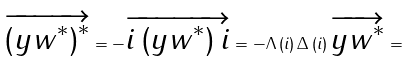Convert formula to latex. <formula><loc_0><loc_0><loc_500><loc_500>\overrightarrow { \left ( y w ^ { \ast } \right ) ^ { \ast } } = - \overrightarrow { i \left ( y w ^ { \ast } \right ) i } = - \Lambda \left ( i \right ) \Delta \left ( i \right ) \overrightarrow { y w ^ { \ast } } =</formula> 